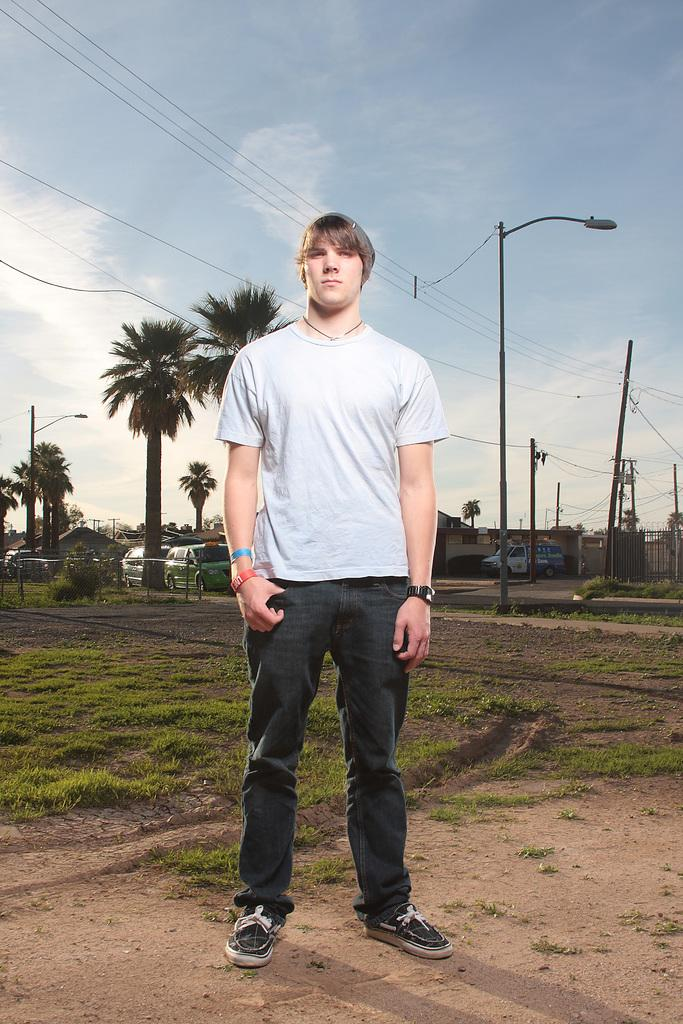What is the main subject in the foreground of the image? There is a man standing in the foreground of the image. What is the man standing on? The man is standing on the ground. What can be seen in the background of the image? There is grass, trees, poles, vehicles, houses, cables, and the sky visible in the background of the image. Can you describe the sky in the image? The sky is visible in the background of the image, and there is a cloud present. What type of milk is being poured into the vehicles in the image? There is no milk or pouring action present in the image; it features a man standing on the ground with various objects in the background. 